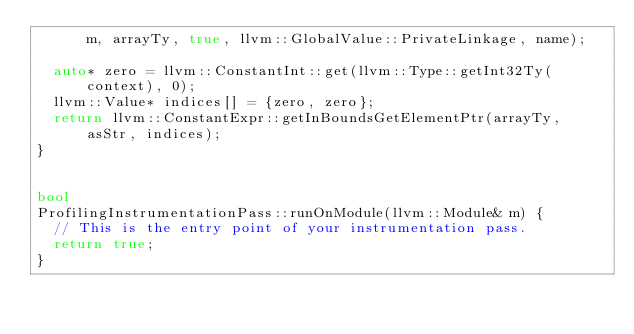<code> <loc_0><loc_0><loc_500><loc_500><_C++_>      m, arrayTy, true, llvm::GlobalValue::PrivateLinkage, name);

  auto* zero = llvm::ConstantInt::get(llvm::Type::getInt32Ty(context), 0);
  llvm::Value* indices[] = {zero, zero};
  return llvm::ConstantExpr::getInBoundsGetElementPtr(arrayTy, asStr, indices);
}


bool
ProfilingInstrumentationPass::runOnModule(llvm::Module& m) {
  // This is the entry point of your instrumentation pass.
  return true;
}

</code> 